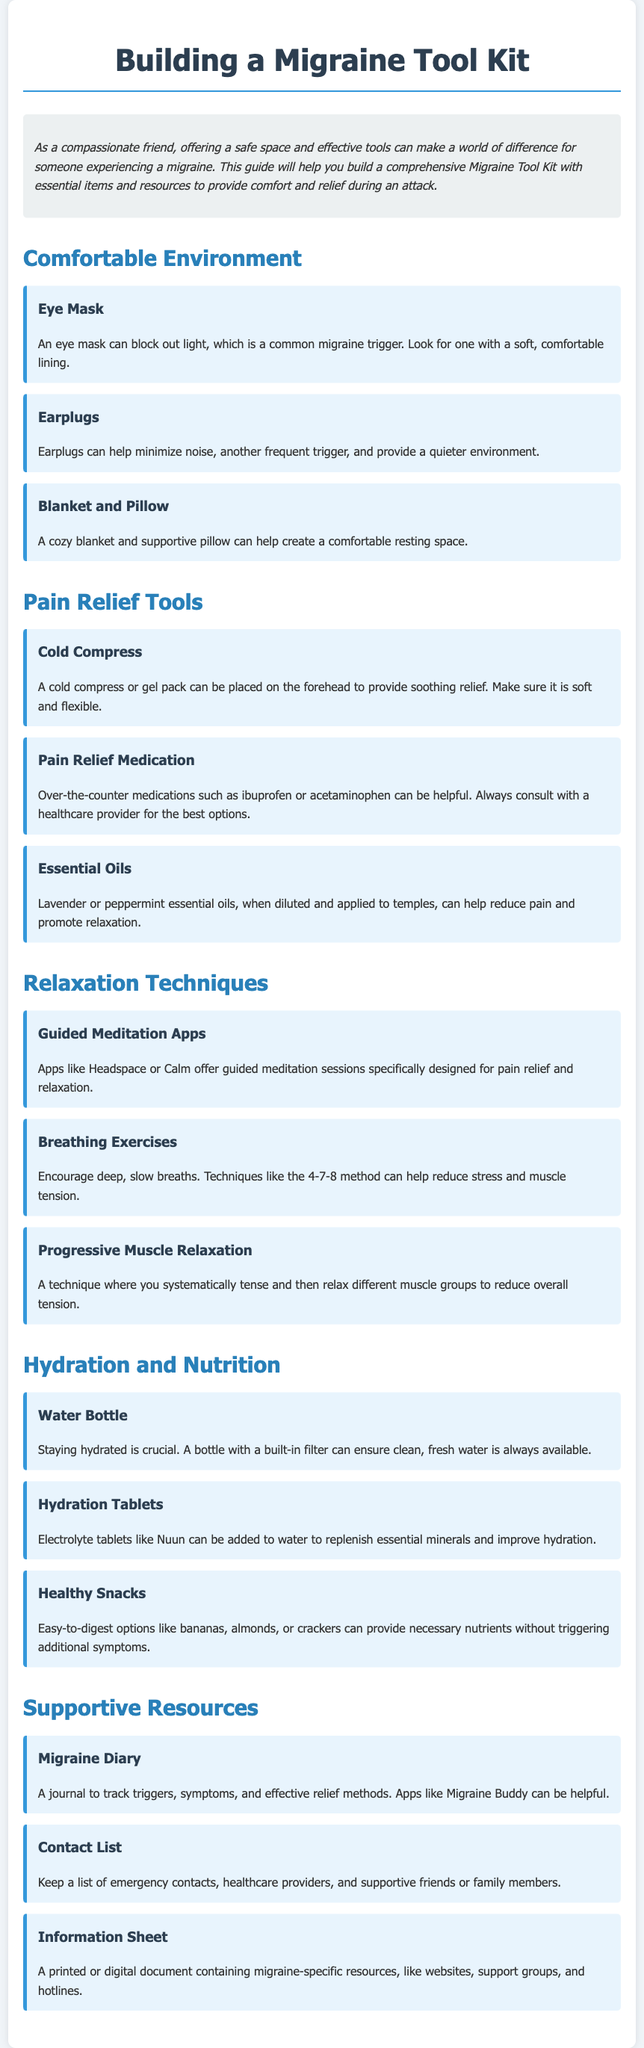What is the purpose of the guide? The guide aims to help build a comprehensive Migraine Tool Kit with essential items and resources to provide comfort and relief during an attack.
Answer: To provide comfort and relief during an attack What item can help block out light? The guide lists several items, among them, the eye mask is specifically designed to block out light, which is a common migraine trigger.
Answer: Eye Mask Which medication is mentioned for pain relief? The guide suggests over-the-counter medications for pain relief, specifically mentioning ibuprofen and acetaminophen.
Answer: Ibuprofen or acetaminophen What are the two types of hydration products listed? The guide includes a water bottle and hydration tablets as important items for hydration during a migraine.
Answer: Water Bottle and Hydration Tablets Name one relaxation technique mentioned. The guide lists several relaxation techniques, including guided meditation apps, which can help during a migraine.
Answer: Guided Meditation Apps What should be used to track triggers and symptoms? For tracking triggers and symptoms, a migraine diary is recommended as an essential tool, with apps like Migraine Buddy suggested.
Answer: Migraine Diary What type of environment should be created during an attack? The guide emphasizes creating a comfortable environment as essential, with tools like earplugs and eye masks to reduce triggers.
Answer: Comfortable Environment How many items are listed under Pain Relief Tools? There are three specific items mentioned under Pain Relief Tools, including a cold compress, pain relief medication, and essential oils.
Answer: Three What is the suggested breathing technique? The guide encourages the use of deep, slow breaths and specifically mentions the 4-7-8 method as a technique to reduce stress.
Answer: 4-7-8 method 